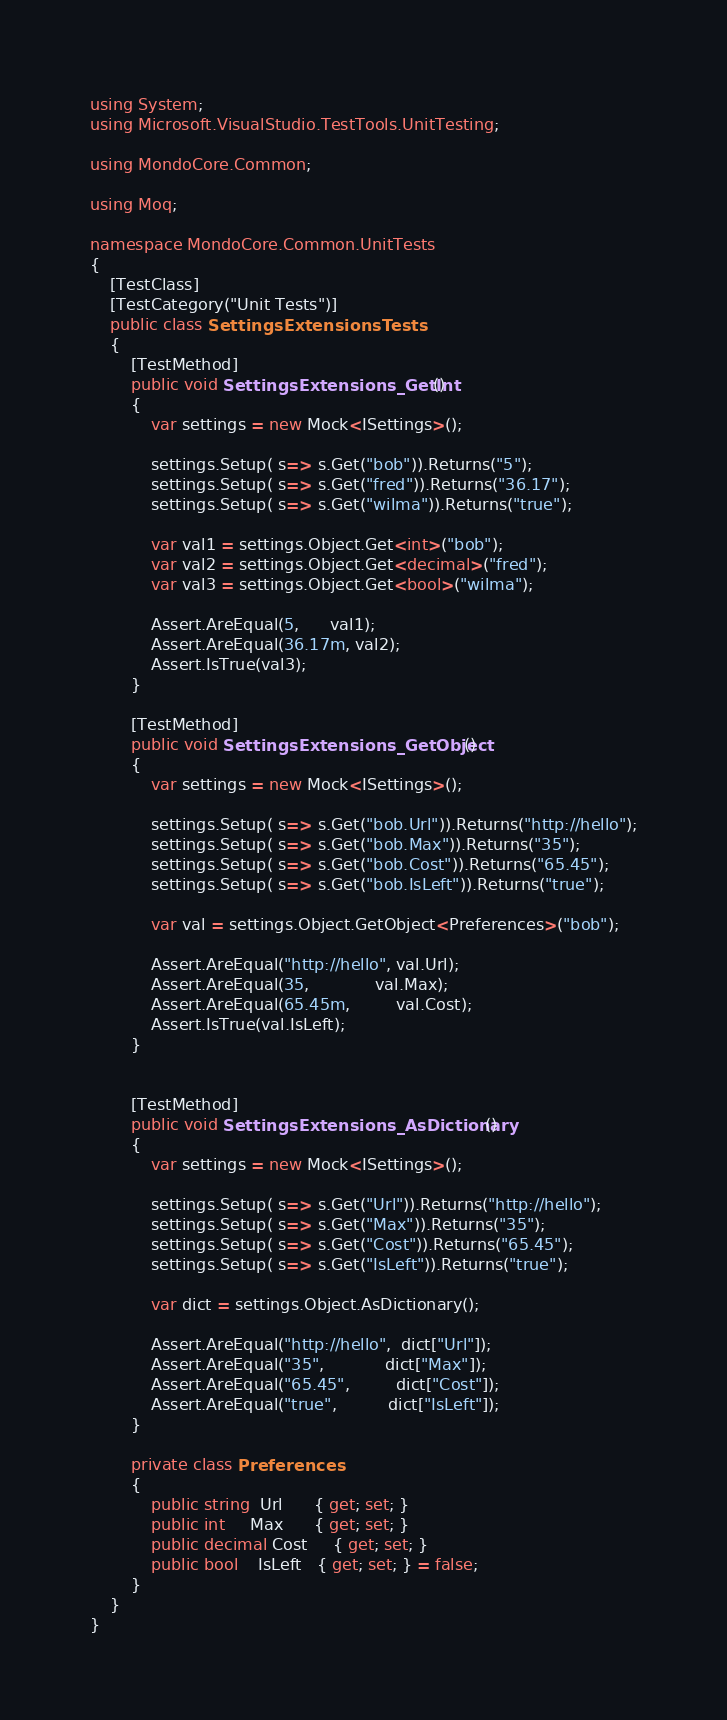Convert code to text. <code><loc_0><loc_0><loc_500><loc_500><_C#_>using System;
using Microsoft.VisualStudio.TestTools.UnitTesting;

using MondoCore.Common;

using Moq;

namespace MondoCore.Common.UnitTests
{
    [TestClass]
    [TestCategory("Unit Tests")]
    public class SettingsExtensionsTests
    {
        [TestMethod]
        public void SettingsExtensions_GetInt()
        {
            var settings = new Mock<ISettings>();

            settings.Setup( s=> s.Get("bob")).Returns("5");
            settings.Setup( s=> s.Get("fred")).Returns("36.17");
            settings.Setup( s=> s.Get("wilma")).Returns("true");

            var val1 = settings.Object.Get<int>("bob");
            var val2 = settings.Object.Get<decimal>("fred");
            var val3 = settings.Object.Get<bool>("wilma");

            Assert.AreEqual(5,      val1);
            Assert.AreEqual(36.17m, val2);
            Assert.IsTrue(val3);
        }

        [TestMethod]
        public void SettingsExtensions_GetObject()
        {
            var settings = new Mock<ISettings>();

            settings.Setup( s=> s.Get("bob.Url")).Returns("http://hello");
            settings.Setup( s=> s.Get("bob.Max")).Returns("35");
            settings.Setup( s=> s.Get("bob.Cost")).Returns("65.45");
            settings.Setup( s=> s.Get("bob.IsLeft")).Returns("true");

            var val = settings.Object.GetObject<Preferences>("bob");

            Assert.AreEqual("http://hello", val.Url);
            Assert.AreEqual(35,             val.Max);
            Assert.AreEqual(65.45m,         val.Cost);
            Assert.IsTrue(val.IsLeft);
        }


        [TestMethod]
        public void SettingsExtensions_AsDictionary()
        {
            var settings = new Mock<ISettings>();

            settings.Setup( s=> s.Get("Url")).Returns("http://hello");
            settings.Setup( s=> s.Get("Max")).Returns("35");
            settings.Setup( s=> s.Get("Cost")).Returns("65.45");
            settings.Setup( s=> s.Get("IsLeft")).Returns("true");

            var dict = settings.Object.AsDictionary();

            Assert.AreEqual("http://hello",  dict["Url"]);
            Assert.AreEqual("35",            dict["Max"]);
            Assert.AreEqual("65.45",         dict["Cost"]);
            Assert.AreEqual("true",          dict["IsLeft"]);
        }

        private class Preferences
        {
            public string  Url      { get; set; }
            public int     Max      { get; set; }
            public decimal Cost     { get; set; }
            public bool    IsLeft   { get; set; } = false;
        }
    }
}
</code> 